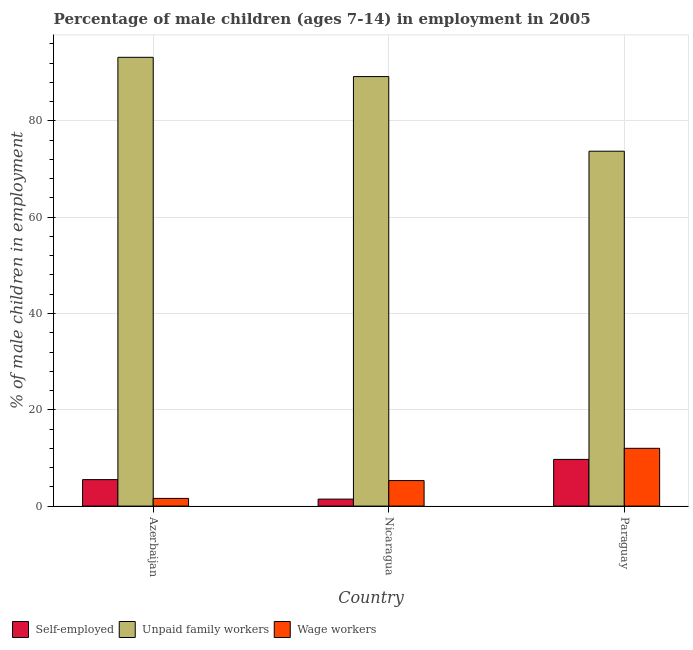How many different coloured bars are there?
Keep it short and to the point. 3. Are the number of bars per tick equal to the number of legend labels?
Give a very brief answer. Yes. How many bars are there on the 1st tick from the left?
Ensure brevity in your answer.  3. How many bars are there on the 3rd tick from the right?
Give a very brief answer. 3. What is the label of the 2nd group of bars from the left?
Offer a very short reply. Nicaragua. What is the percentage of children employed as unpaid family workers in Paraguay?
Give a very brief answer. 73.7. Across all countries, what is the maximum percentage of children employed as unpaid family workers?
Your answer should be compact. 93.2. Across all countries, what is the minimum percentage of children employed as unpaid family workers?
Keep it short and to the point. 73.7. In which country was the percentage of self employed children maximum?
Give a very brief answer. Paraguay. In which country was the percentage of self employed children minimum?
Make the answer very short. Nicaragua. What is the total percentage of children employed as wage workers in the graph?
Offer a terse response. 18.9. What is the difference between the percentage of children employed as wage workers in Azerbaijan and that in Nicaragua?
Your response must be concise. -3.7. What is the difference between the percentage of children employed as wage workers in Azerbaijan and the percentage of children employed as unpaid family workers in Nicaragua?
Give a very brief answer. -87.6. What is the average percentage of children employed as unpaid family workers per country?
Your answer should be compact. 85.37. What is the difference between the percentage of children employed as wage workers and percentage of children employed as unpaid family workers in Azerbaijan?
Offer a terse response. -91.6. In how many countries, is the percentage of children employed as unpaid family workers greater than 20 %?
Provide a short and direct response. 3. What is the ratio of the percentage of children employed as unpaid family workers in Azerbaijan to that in Nicaragua?
Ensure brevity in your answer.  1.04. Is the percentage of children employed as unpaid family workers in Nicaragua less than that in Paraguay?
Provide a succinct answer. No. Is the difference between the percentage of self employed children in Azerbaijan and Paraguay greater than the difference between the percentage of children employed as wage workers in Azerbaijan and Paraguay?
Give a very brief answer. Yes. In how many countries, is the percentage of children employed as wage workers greater than the average percentage of children employed as wage workers taken over all countries?
Provide a short and direct response. 1. Is the sum of the percentage of children employed as unpaid family workers in Azerbaijan and Paraguay greater than the maximum percentage of children employed as wage workers across all countries?
Your answer should be very brief. Yes. What does the 3rd bar from the left in Nicaragua represents?
Give a very brief answer. Wage workers. What does the 3rd bar from the right in Nicaragua represents?
Give a very brief answer. Self-employed. Where does the legend appear in the graph?
Ensure brevity in your answer.  Bottom left. What is the title of the graph?
Give a very brief answer. Percentage of male children (ages 7-14) in employment in 2005. What is the label or title of the Y-axis?
Give a very brief answer. % of male children in employment. What is the % of male children in employment in Self-employed in Azerbaijan?
Your response must be concise. 5.5. What is the % of male children in employment in Unpaid family workers in Azerbaijan?
Give a very brief answer. 93.2. What is the % of male children in employment in Wage workers in Azerbaijan?
Offer a terse response. 1.6. What is the % of male children in employment of Self-employed in Nicaragua?
Make the answer very short. 1.45. What is the % of male children in employment of Unpaid family workers in Nicaragua?
Offer a terse response. 89.2. What is the % of male children in employment in Wage workers in Nicaragua?
Offer a very short reply. 5.3. What is the % of male children in employment of Self-employed in Paraguay?
Give a very brief answer. 9.7. What is the % of male children in employment in Unpaid family workers in Paraguay?
Provide a succinct answer. 73.7. Across all countries, what is the maximum % of male children in employment in Self-employed?
Offer a very short reply. 9.7. Across all countries, what is the maximum % of male children in employment in Unpaid family workers?
Provide a succinct answer. 93.2. Across all countries, what is the maximum % of male children in employment of Wage workers?
Make the answer very short. 12. Across all countries, what is the minimum % of male children in employment in Self-employed?
Offer a terse response. 1.45. Across all countries, what is the minimum % of male children in employment of Unpaid family workers?
Make the answer very short. 73.7. Across all countries, what is the minimum % of male children in employment of Wage workers?
Your response must be concise. 1.6. What is the total % of male children in employment in Self-employed in the graph?
Give a very brief answer. 16.65. What is the total % of male children in employment of Unpaid family workers in the graph?
Your answer should be very brief. 256.1. What is the difference between the % of male children in employment of Self-employed in Azerbaijan and that in Nicaragua?
Provide a succinct answer. 4.05. What is the difference between the % of male children in employment in Self-employed in Azerbaijan and that in Paraguay?
Provide a short and direct response. -4.2. What is the difference between the % of male children in employment in Unpaid family workers in Azerbaijan and that in Paraguay?
Make the answer very short. 19.5. What is the difference between the % of male children in employment of Self-employed in Nicaragua and that in Paraguay?
Your answer should be compact. -8.25. What is the difference between the % of male children in employment of Self-employed in Azerbaijan and the % of male children in employment of Unpaid family workers in Nicaragua?
Your response must be concise. -83.7. What is the difference between the % of male children in employment in Self-employed in Azerbaijan and the % of male children in employment in Wage workers in Nicaragua?
Provide a short and direct response. 0.2. What is the difference between the % of male children in employment of Unpaid family workers in Azerbaijan and the % of male children in employment of Wage workers in Nicaragua?
Your response must be concise. 87.9. What is the difference between the % of male children in employment of Self-employed in Azerbaijan and the % of male children in employment of Unpaid family workers in Paraguay?
Your answer should be very brief. -68.2. What is the difference between the % of male children in employment in Self-employed in Azerbaijan and the % of male children in employment in Wage workers in Paraguay?
Keep it short and to the point. -6.5. What is the difference between the % of male children in employment in Unpaid family workers in Azerbaijan and the % of male children in employment in Wage workers in Paraguay?
Make the answer very short. 81.2. What is the difference between the % of male children in employment of Self-employed in Nicaragua and the % of male children in employment of Unpaid family workers in Paraguay?
Your response must be concise. -72.25. What is the difference between the % of male children in employment in Self-employed in Nicaragua and the % of male children in employment in Wage workers in Paraguay?
Your answer should be compact. -10.55. What is the difference between the % of male children in employment of Unpaid family workers in Nicaragua and the % of male children in employment of Wage workers in Paraguay?
Your answer should be compact. 77.2. What is the average % of male children in employment in Self-employed per country?
Your answer should be very brief. 5.55. What is the average % of male children in employment in Unpaid family workers per country?
Your answer should be compact. 85.37. What is the difference between the % of male children in employment in Self-employed and % of male children in employment in Unpaid family workers in Azerbaijan?
Your answer should be compact. -87.7. What is the difference between the % of male children in employment in Unpaid family workers and % of male children in employment in Wage workers in Azerbaijan?
Provide a short and direct response. 91.6. What is the difference between the % of male children in employment in Self-employed and % of male children in employment in Unpaid family workers in Nicaragua?
Keep it short and to the point. -87.75. What is the difference between the % of male children in employment in Self-employed and % of male children in employment in Wage workers in Nicaragua?
Give a very brief answer. -3.85. What is the difference between the % of male children in employment of Unpaid family workers and % of male children in employment of Wage workers in Nicaragua?
Ensure brevity in your answer.  83.9. What is the difference between the % of male children in employment in Self-employed and % of male children in employment in Unpaid family workers in Paraguay?
Your answer should be compact. -64. What is the difference between the % of male children in employment of Self-employed and % of male children in employment of Wage workers in Paraguay?
Make the answer very short. -2.3. What is the difference between the % of male children in employment of Unpaid family workers and % of male children in employment of Wage workers in Paraguay?
Make the answer very short. 61.7. What is the ratio of the % of male children in employment in Self-employed in Azerbaijan to that in Nicaragua?
Give a very brief answer. 3.79. What is the ratio of the % of male children in employment of Unpaid family workers in Azerbaijan to that in Nicaragua?
Ensure brevity in your answer.  1.04. What is the ratio of the % of male children in employment of Wage workers in Azerbaijan to that in Nicaragua?
Offer a very short reply. 0.3. What is the ratio of the % of male children in employment of Self-employed in Azerbaijan to that in Paraguay?
Your answer should be very brief. 0.57. What is the ratio of the % of male children in employment in Unpaid family workers in Azerbaijan to that in Paraguay?
Give a very brief answer. 1.26. What is the ratio of the % of male children in employment of Wage workers in Azerbaijan to that in Paraguay?
Provide a succinct answer. 0.13. What is the ratio of the % of male children in employment in Self-employed in Nicaragua to that in Paraguay?
Provide a succinct answer. 0.15. What is the ratio of the % of male children in employment in Unpaid family workers in Nicaragua to that in Paraguay?
Make the answer very short. 1.21. What is the ratio of the % of male children in employment in Wage workers in Nicaragua to that in Paraguay?
Provide a short and direct response. 0.44. What is the difference between the highest and the second highest % of male children in employment in Self-employed?
Provide a succinct answer. 4.2. What is the difference between the highest and the second highest % of male children in employment of Unpaid family workers?
Ensure brevity in your answer.  4. What is the difference between the highest and the second highest % of male children in employment in Wage workers?
Provide a succinct answer. 6.7. What is the difference between the highest and the lowest % of male children in employment in Self-employed?
Keep it short and to the point. 8.25. 